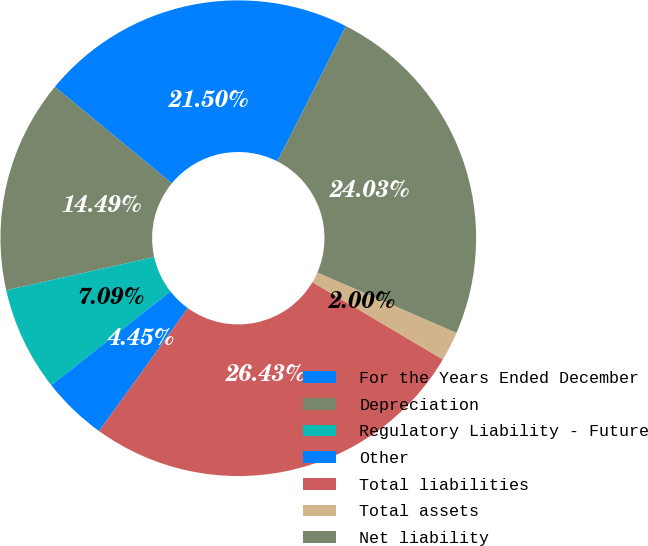Convert chart to OTSL. <chart><loc_0><loc_0><loc_500><loc_500><pie_chart><fcel>For the Years Ended December<fcel>Depreciation<fcel>Regulatory Liability - Future<fcel>Other<fcel>Total liabilities<fcel>Total assets<fcel>Net liability<nl><fcel>21.5%<fcel>14.49%<fcel>7.09%<fcel>4.45%<fcel>26.43%<fcel>2.0%<fcel>24.03%<nl></chart> 